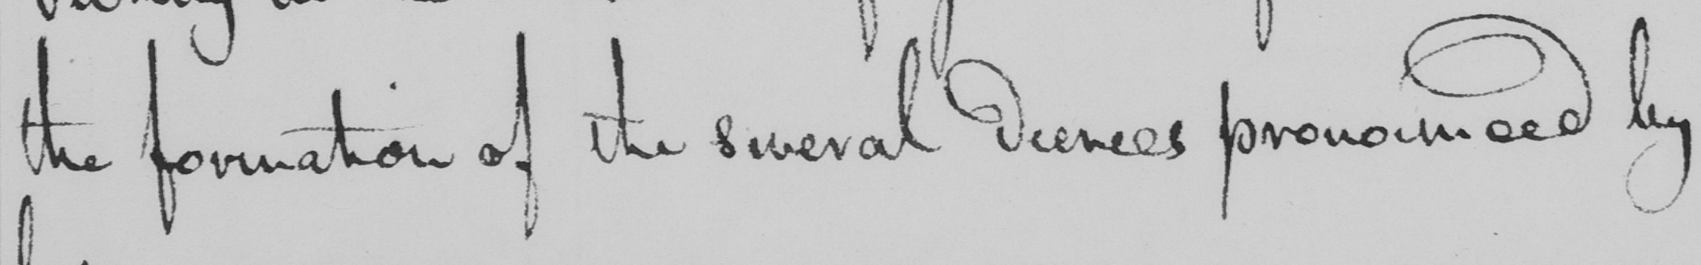Please transcribe the handwritten text in this image. the formation of the several decrees pronounced by 